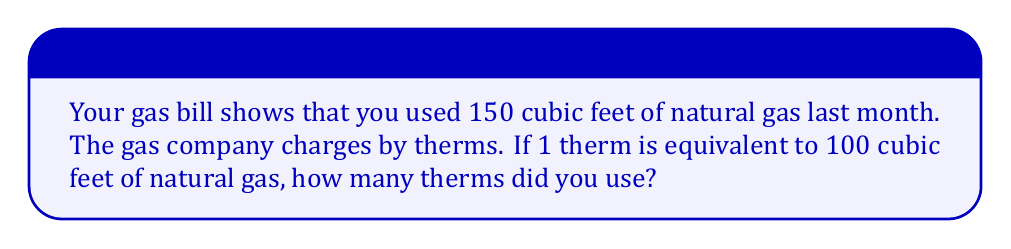Can you solve this math problem? To solve this problem, we need to convert cubic feet to therms. Let's break it down step by step:

1. We know that:
   - You used 150 cubic feet of natural gas
   - 1 therm = 100 cubic feet of natural gas

2. To find the number of therms, we need to divide the total cubic feet by the number of cubic feet in one therm:

   $$ \text{Therms} = \frac{\text{Total cubic feet}}{\text{Cubic feet per therm}} $$

3. Plugging in the values:

   $$ \text{Therms} = \frac{150 \text{ cubic feet}}{100 \text{ cubic feet per therm}} $$

4. Simplify the fraction:

   $$ \text{Therms} = \frac{150}{100} = 1.5 $$

Therefore, you used 1.5 therms of natural gas last month.
Answer: 1.5 therms 